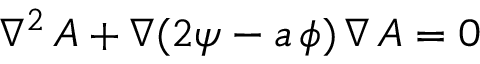Convert formula to latex. <formula><loc_0><loc_0><loc_500><loc_500>\nabla ^ { 2 } \, A + \nabla ( 2 \psi - a \, \phi ) \, \nabla \, A = 0</formula> 